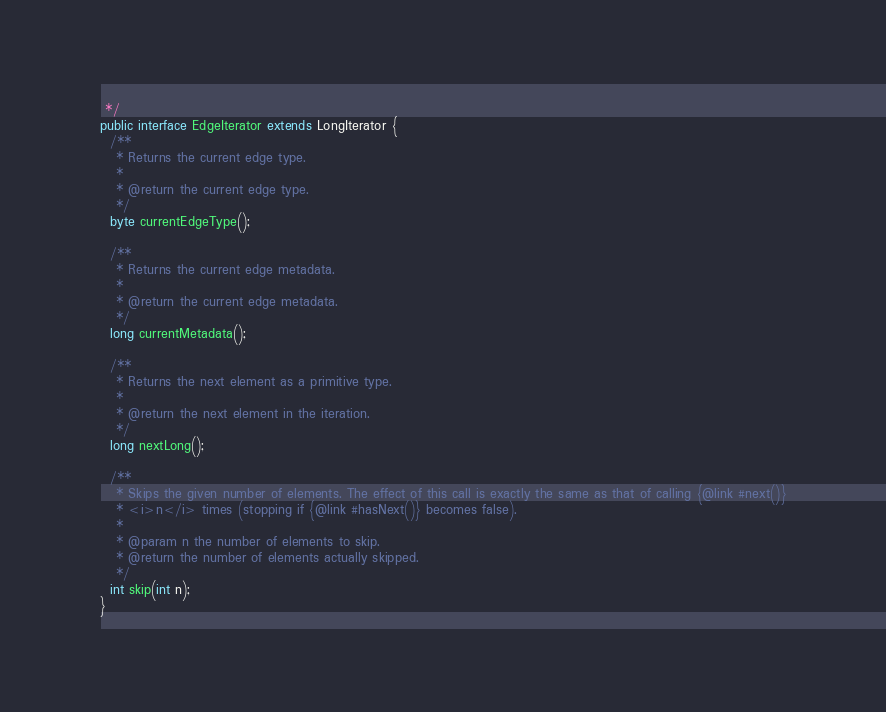<code> <loc_0><loc_0><loc_500><loc_500><_Java_> */
public interface EdgeIterator extends LongIterator {
  /**
   * Returns the current edge type.
   *
   * @return the current edge type.
   */
  byte currentEdgeType();

  /**
   * Returns the current edge metadata.
   *
   * @return the current edge metadata.
   */
  long currentMetadata();

  /**
   * Returns the next element as a primitive type.
   *
   * @return the next element in the iteration.
   */
  long nextLong();

  /**
   * Skips the given number of elements. The effect of this call is exactly the same as that of calling {@link #next()}
   * <i>n</i> times (stopping if {@link #hasNext()} becomes false).
   *
   * @param n the number of elements to skip.
   * @return the number of elements actually skipped.
   */
  int skip(int n);
}
</code> 